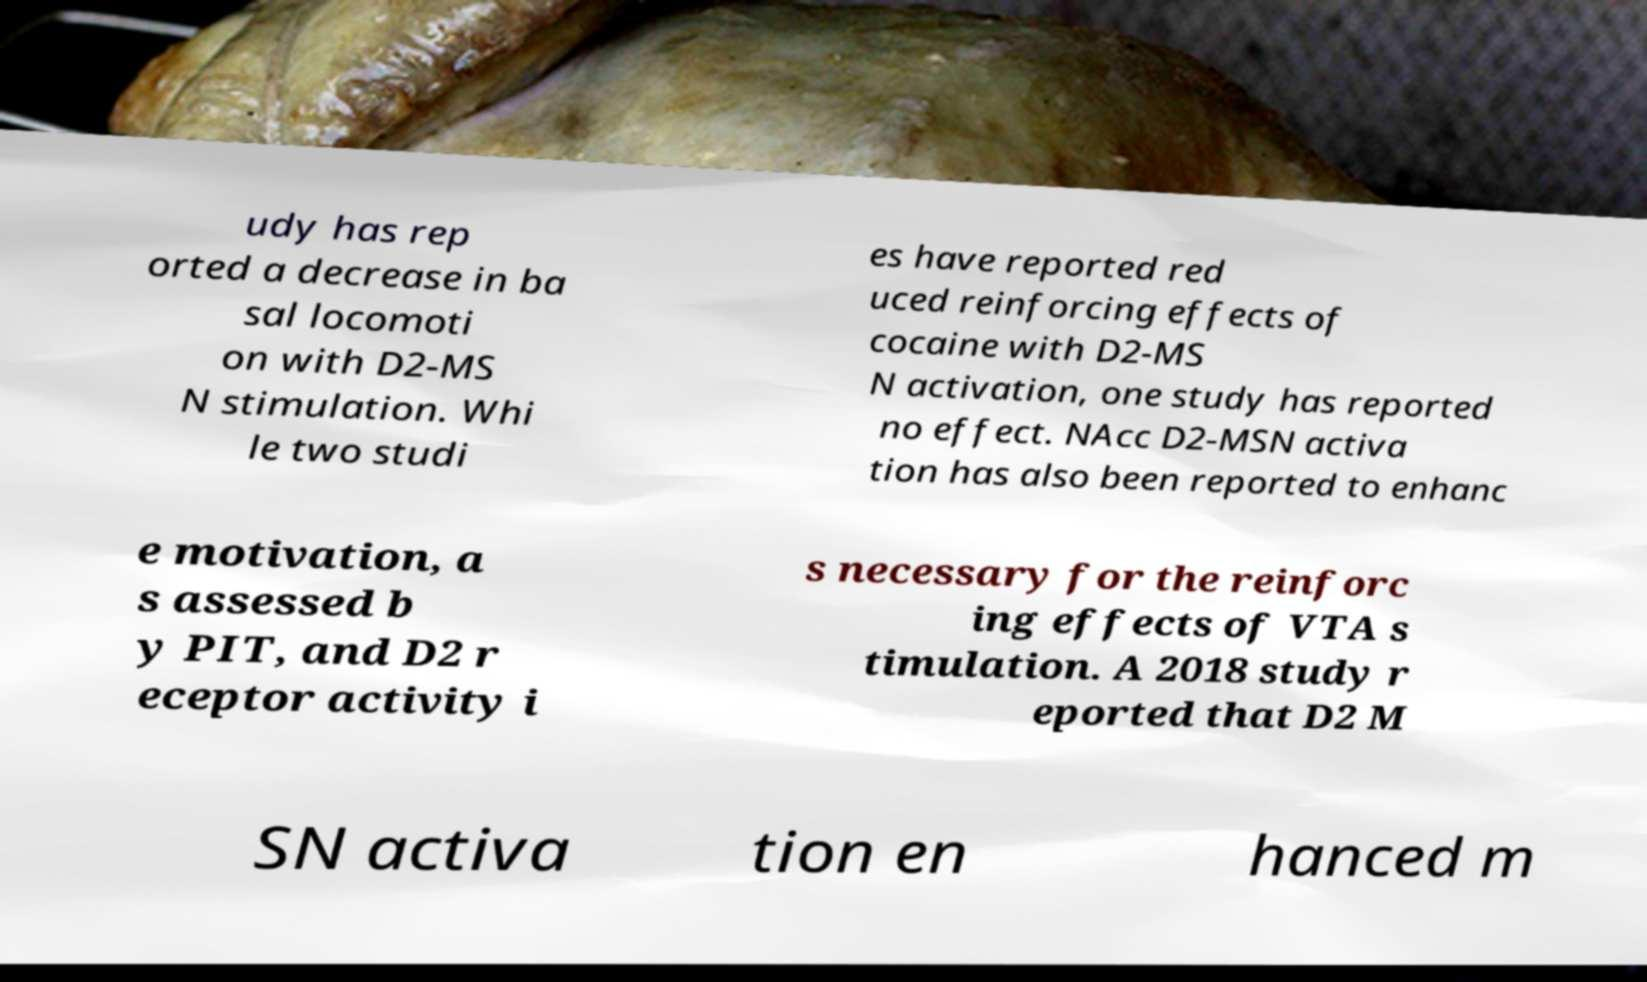What messages or text are displayed in this image? I need them in a readable, typed format. udy has rep orted a decrease in ba sal locomoti on with D2-MS N stimulation. Whi le two studi es have reported red uced reinforcing effects of cocaine with D2-MS N activation, one study has reported no effect. NAcc D2-MSN activa tion has also been reported to enhanc e motivation, a s assessed b y PIT, and D2 r eceptor activity i s necessary for the reinforc ing effects of VTA s timulation. A 2018 study r eported that D2 M SN activa tion en hanced m 